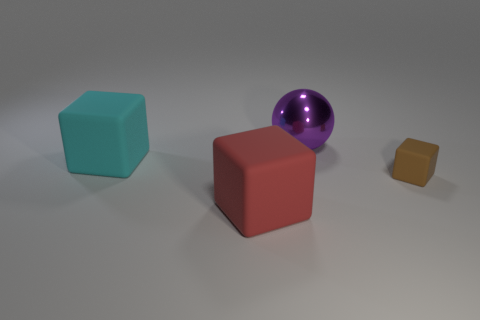Does the cyan object have the same size as the red object that is in front of the brown thing?
Your answer should be compact. Yes. What color is the object that is on the right side of the big purple object?
Your answer should be very brief. Brown. How many red things are large matte things or big things?
Your response must be concise. 1. The small matte cube is what color?
Provide a short and direct response. Brown. Is there anything else that has the same material as the purple thing?
Ensure brevity in your answer.  No. Is the number of big purple shiny spheres behind the purple shiny ball less than the number of red objects in front of the cyan rubber object?
Offer a very short reply. Yes. What shape is the thing that is both on the left side of the big purple metallic thing and in front of the big cyan thing?
Provide a short and direct response. Cube. What number of large cyan things have the same shape as the small thing?
Your answer should be very brief. 1. There is a cyan block that is the same material as the red thing; what is its size?
Your answer should be very brief. Large. How many purple things have the same size as the brown matte cube?
Offer a very short reply. 0. 